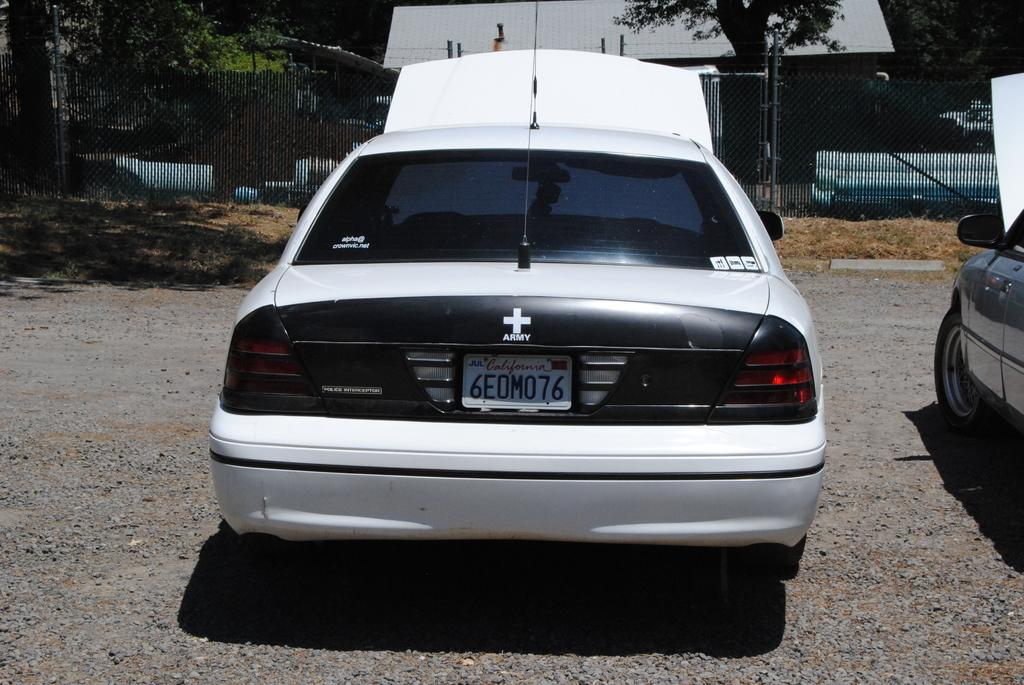What type of vehicles can be seen on the ground in the image? There are cars on the ground in the image. What type of natural elements are visible in the image? There are stones and plants visible in the image. What type of barrier is present in the image? There is a metal fence in the image. What type of structures are present in the image? There are poles and a house with a roof in the image. What type of vegetation can be seen in the image? There is a group of trees in the image. What type of stew is being cooked in the image? There is no stew present in the image; it features cars, stones, plants, a metal fence, poles, a house with a roof, and a group of trees. What type of arch can be seen in the image? There is no arch present in the image. 